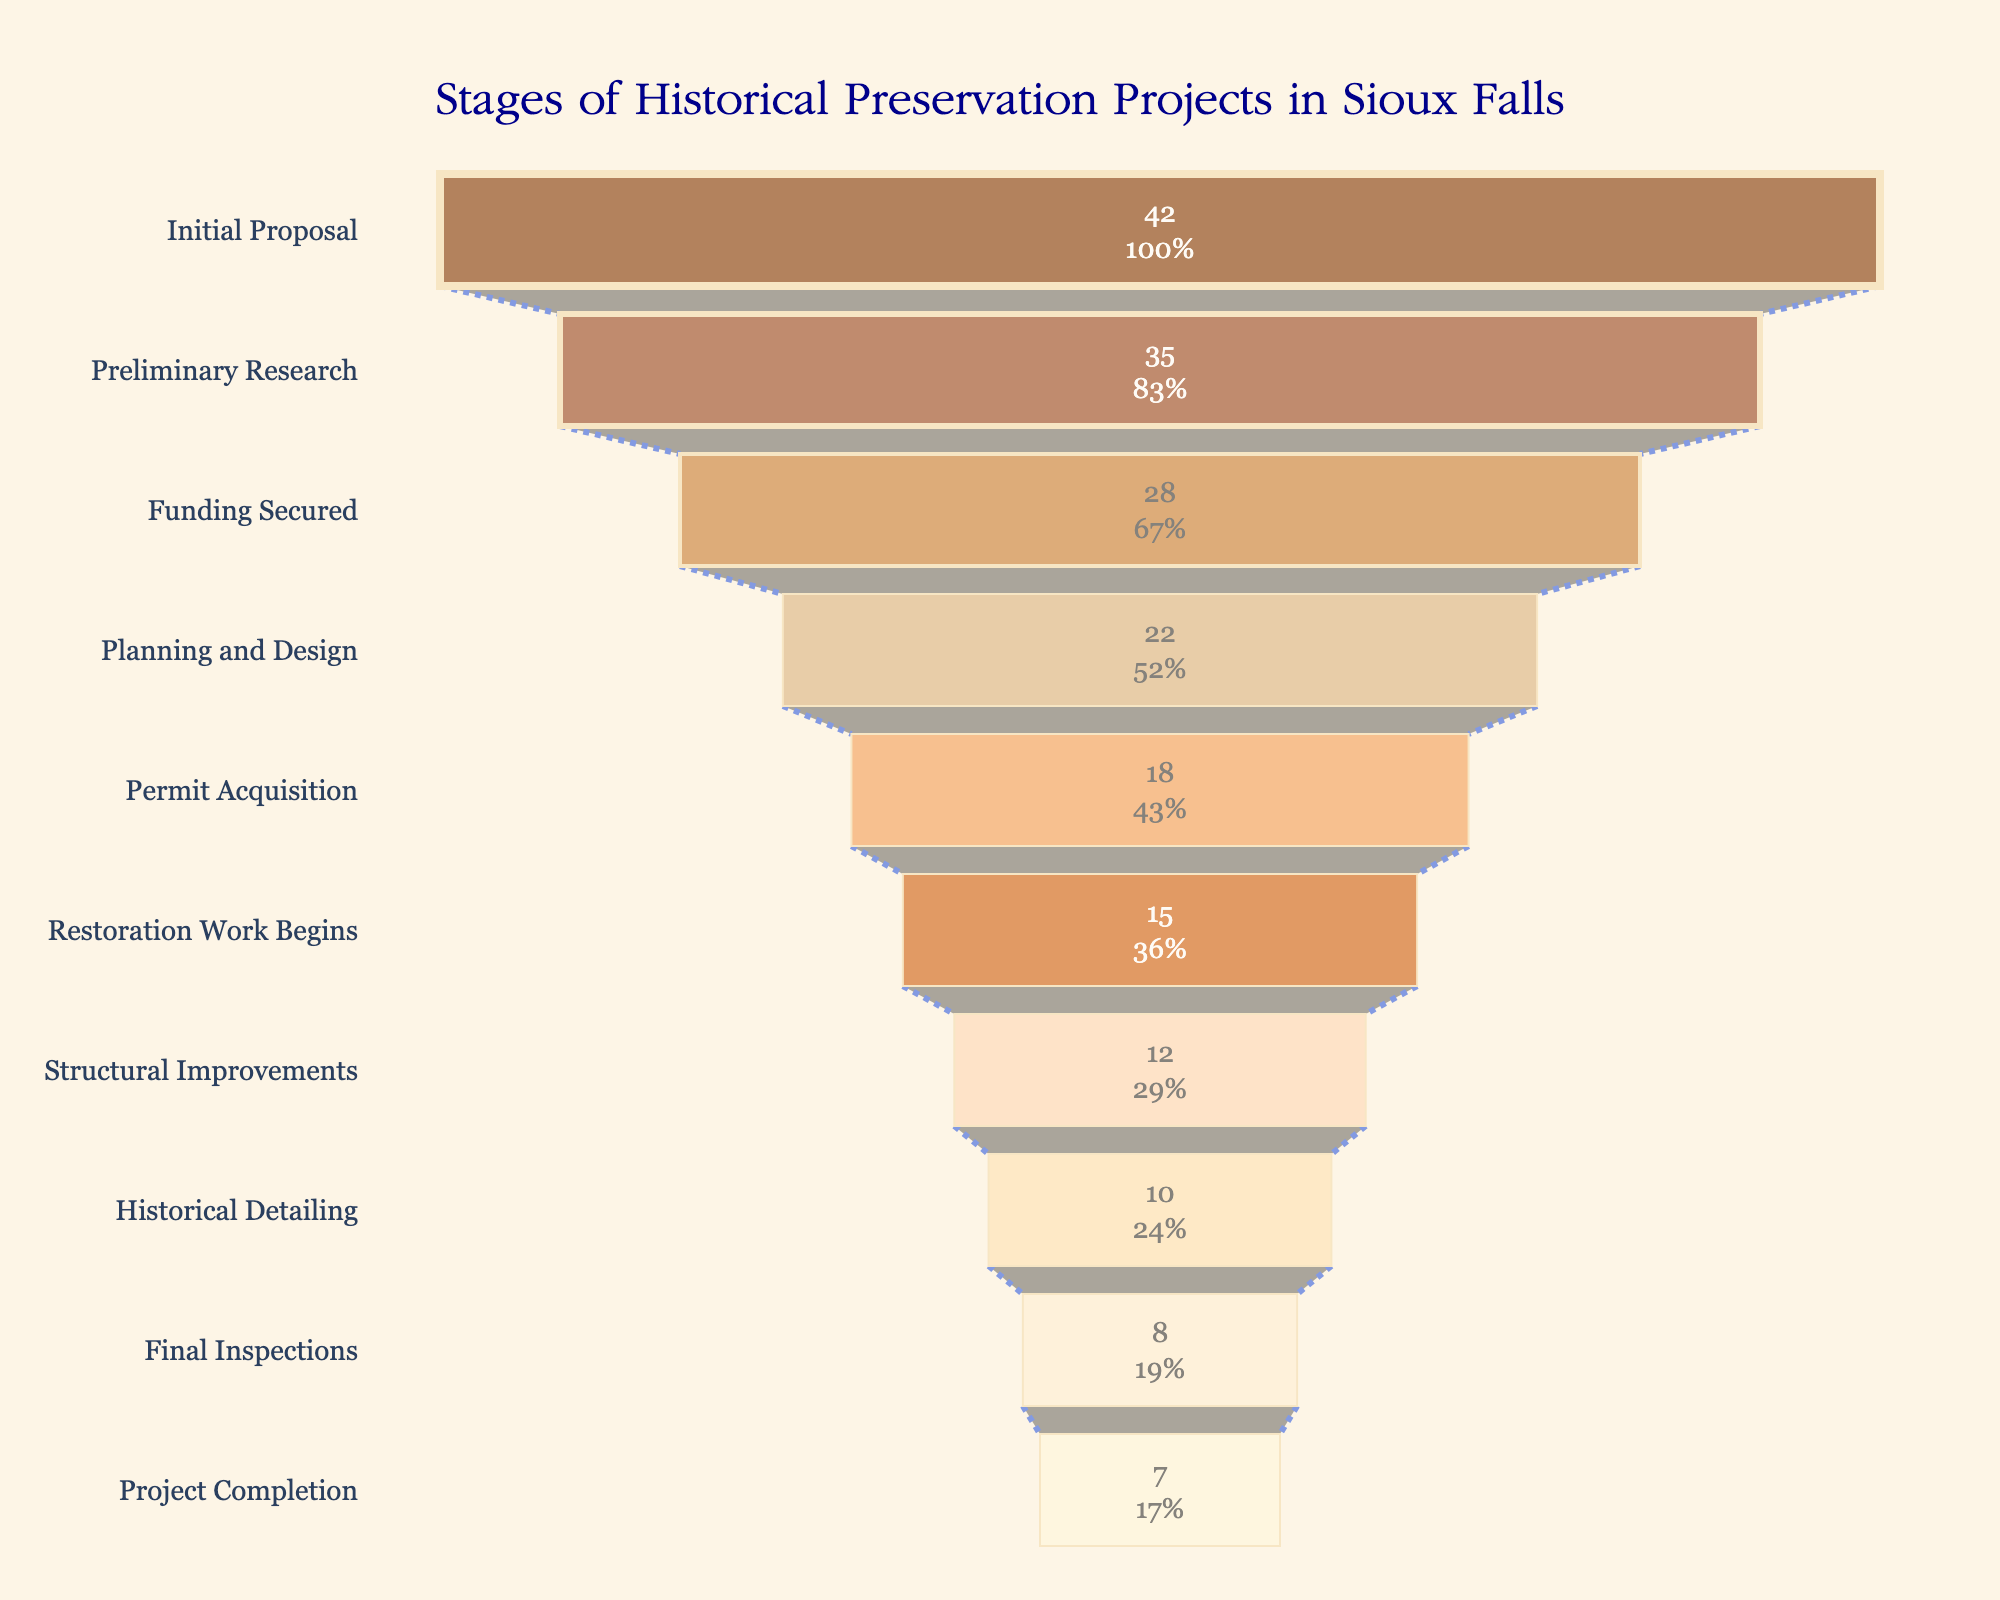What's the title of the funnel chart? The title of the funnel chart is located at the top center of the figure. It reads "Stages of Historical Preservation Projects in Sioux Falls".
Answer: "Stages of Historical Preservation Projects in Sioux Falls" What is the total number of projects in the Initial Proposal stage? The Initial Proposal stage is the first stage listed in the funnel chart. It indicates the number of projects at that stage directly on the chart.
Answer: 42 Which stage shows the highest number of projects? To find this, look for the stage with the largest number of projects in the funnel chart. The Initial Proposal stage has the highest number of projects.
Answer: Initial Proposal How many stages exist between the Initial Proposal and Project Completion stages? Count all the stages listed in the funnel chart from Initial Proposal to Project Completion inclusive, and subtract 2 (one for each end stage). There are 10 stages in total; removing the first and last leaves us with 8 stages.
Answer: 8 By how many projects does the number of projects decrease from Preliminary Research to Funding Secured? Find the number of projects at the Preliminary Research stage (35) and the Funding Secured stage (28), then subtract the latter from the former: 35 - 28 = 7.
Answer: 7 What percentage of the initial projects reach the Historical Detailing stage? The Historical Detailing stage has 10 projects. To find this as a percentage of the Initial Proposal stage (42), calculate (10/42)*100. Step-by-step: 10 divided by 42 is approximately 0.238, and multiplying by 100 gives about 23.8%.
Answer: ~23.8% Which stage sees the smallest group of projects? Locate the stage with the lowest number of projects in the funnel chart. The Project Completion stage, with 7 projects, is the smallest.
Answer: Project Completion What is the approximate percentage decline from the Initial Proposal to Project Completion stage? Calculate the initial number of projects (42) and the final stage number (7). The decline is (42 - 7). Then, to find the percentage decline, divide by the initial number (42) and multiply by 100: ((42-7)/42)*100 is approximately 83.3%.
Answer: ~83.3% How do the number of projects in Planning and Design compare to those in Permit Acquisition? The Planning and Design stage has 22 projects, while the Permit Acquisition stage has 18 projects. Comparing these values, 22 is greater than 18.
Answer: Planning and Design > Permit Acquisition 